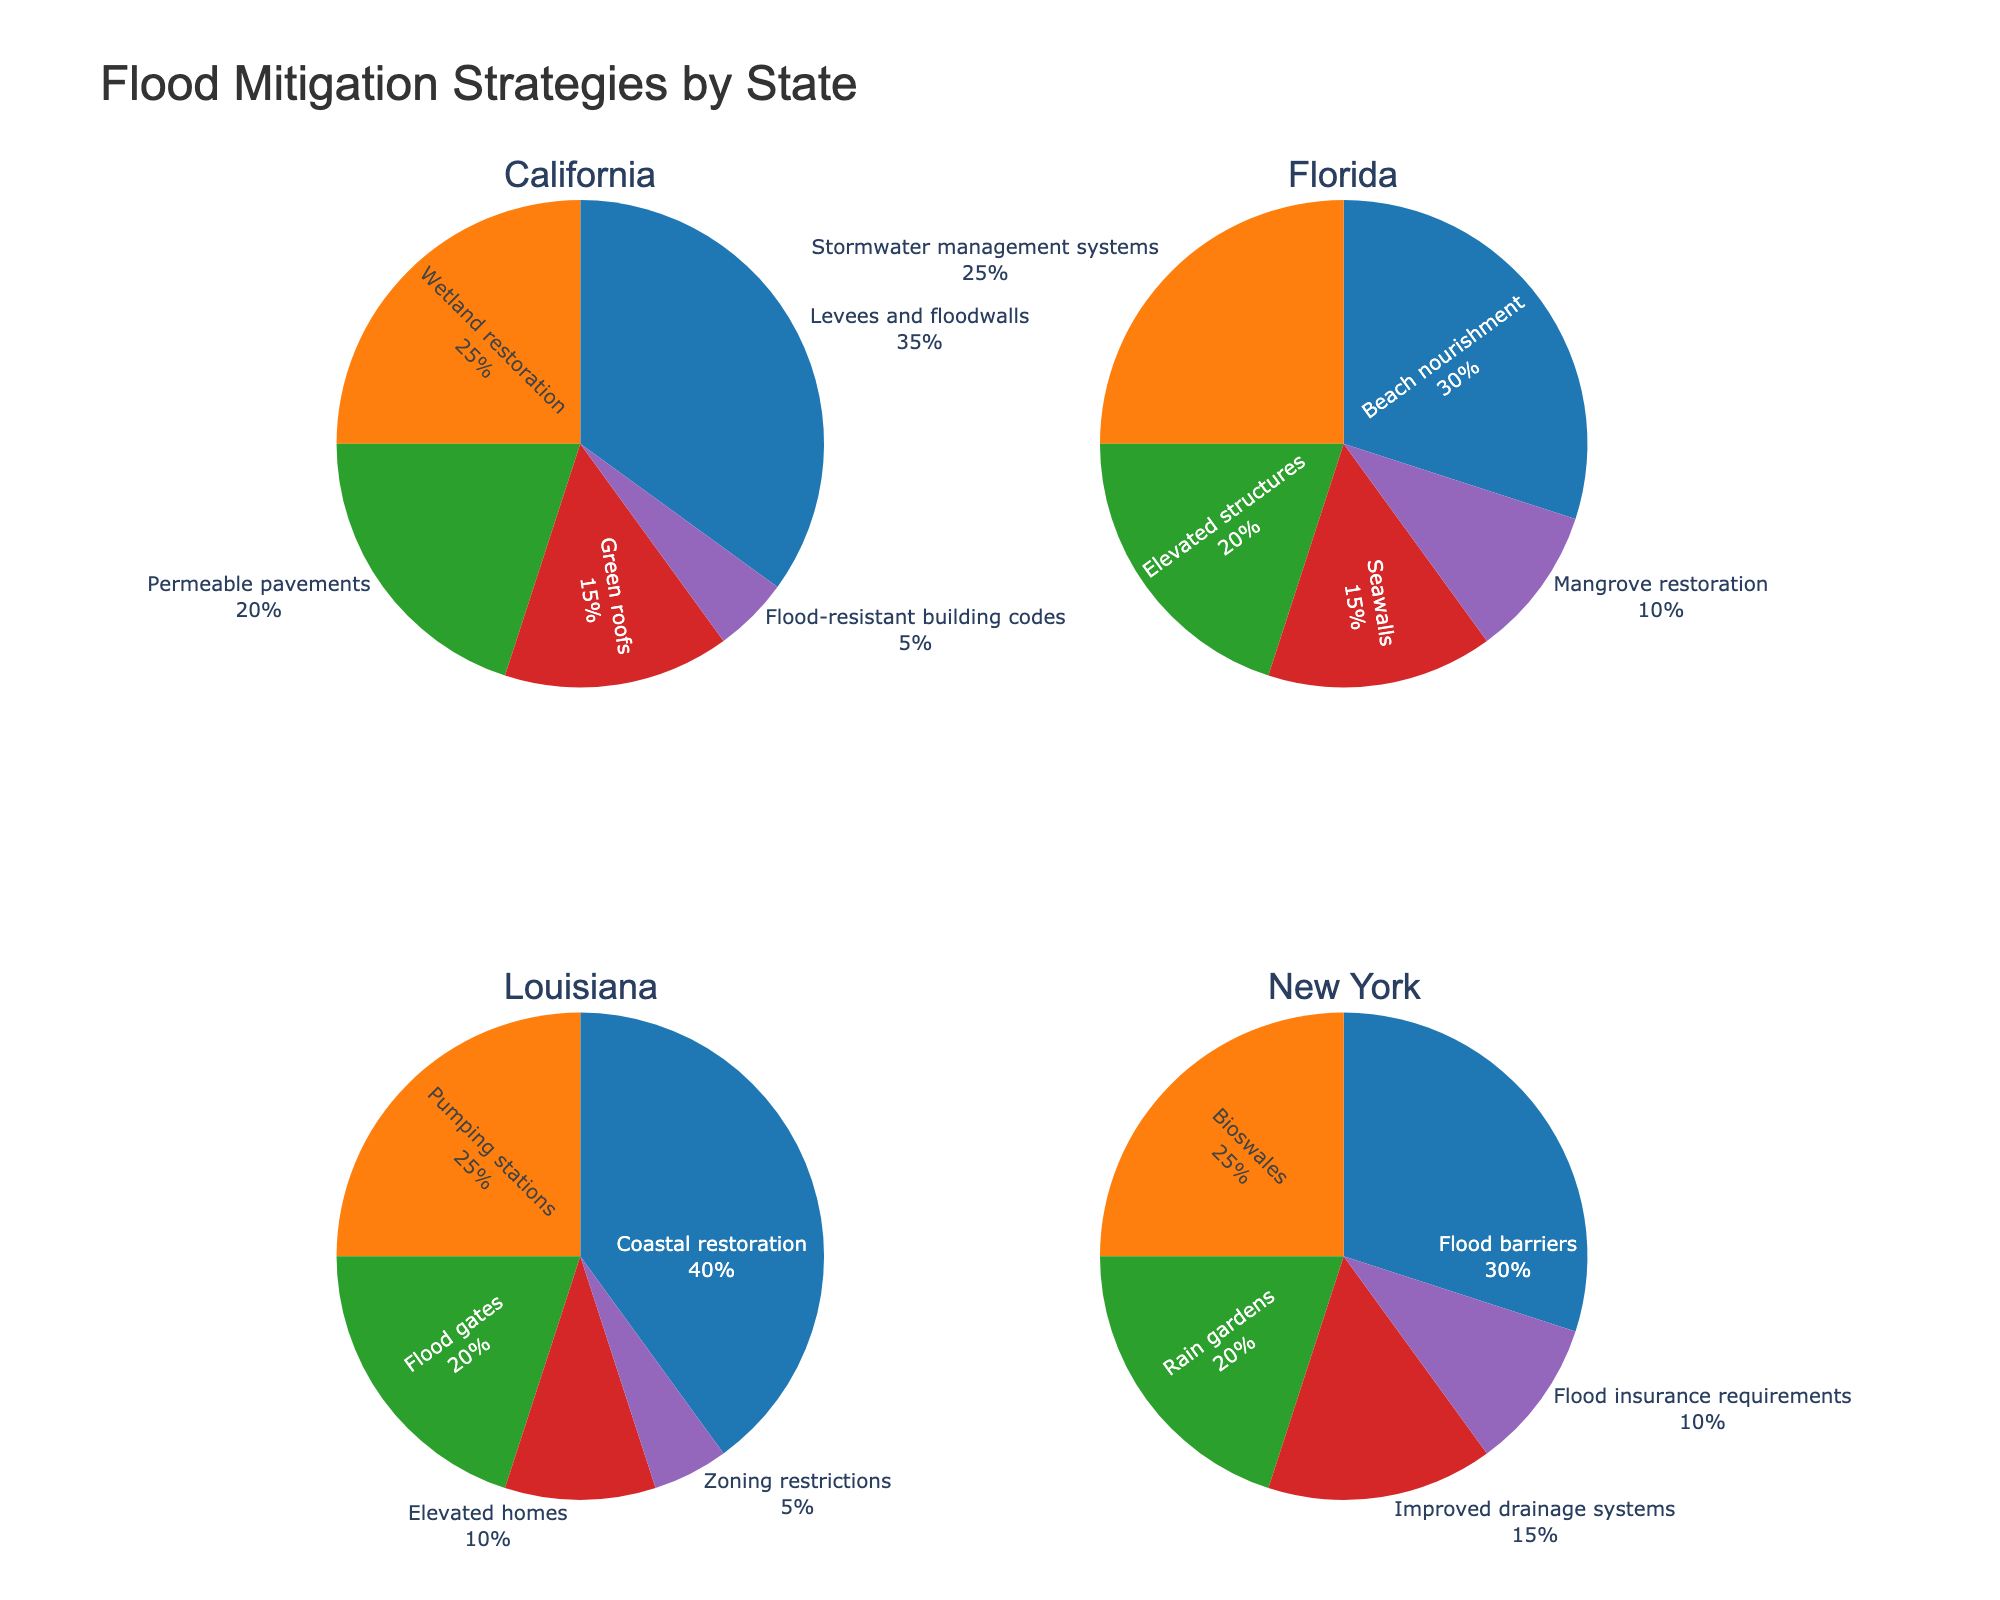what is the primary flood mitigation strategy in Louisiana? In the pie chart for Louisiana, the largest section corresponds to "Coastal restoration," occupying 40%. This suggests it is the primary strategy.
Answer: Coastal restoration What percentage of flood mitigation strategies in California consist of wetland restoration and permeable pavements combined? In the pie chart for California, wetland restoration is 25% and permeable pavements are 20%. Adding those percentages gives 25% + 20% = 45%.
Answer: 45% Which state has the highest percentage allocated to a single flood mitigation strategy? Comparing the largest segments of each state's pie charts, Louisiana's 40% for coastal restoration is the highest.
Answer: Louisiana How does the percentage for green roofs in California compare to the percentage for rain gardens in New York? California's pie chart shows 15% for green roofs, while New York's pie chart shows 20% for rain gardens. Therefore, rain gardens in New York are 5% more.
Answer: New York is 5% higher What are the unique flood mitigation strategies seen in Florida but not in other states displayed in the figure? Florida has strategies like beach nourishment, stormwater management systems, elevated structures, and mangrove restoration that are not listed in other states' pie charts.
Answer: Beach nourishment, stormwater management systems, elevated structures, and mangrove restoration What is the combined percentage for all flood mitigation strategies that involve restoring natural environments across the states mentioned? California: Wetland restoration (25%), Florida: Mangrove restoration (10%), Louisiana: Coastal restoration (40%). Adding these, 25% + 10% + 40% = 75%.
Answer: 75% Which state has the smallest percentage assigned to the least utilized strategy, and what is that strategy? Among all states, "Zoning restrictions" in Louisiana and "Flood-resistant building codes" in California both have the smallest percentage at 5%.
Answer: Louisiana or California each with 5% How does the share of stormwater management systems in Florida compare to the share of pumping stations in Louisiana? The pie chart for Florida shows 25% for stormwater management systems, and Louisiana's pie chart shows 25% for pumping stations. Therefore, they are equal.
Answer: Equal (25%) Which flood mitigation strategy appears to be the most frequently implemented across different states? By looking at all the pie charts, strategies like levees and floodwalls, coastal restoration, and flood barriers appear in multiple states, but none are in all. Coastal restoration is prominent with the highest percentage allocation.
Answer: Coastal restoration Considering all states, what is the average percentage for the most commonly utilized flood mitigation strategy within each state? Identifying the top strategies: California: Levees and floodwalls (35%), Florida: Beach nourishment (30%), Louisiana: Coastal restoration (40%), New York: Flood barriers (30%). Average = (35 + 30 + 40 + 30) / 4 = 33.75%.
Answer: 33.75% 